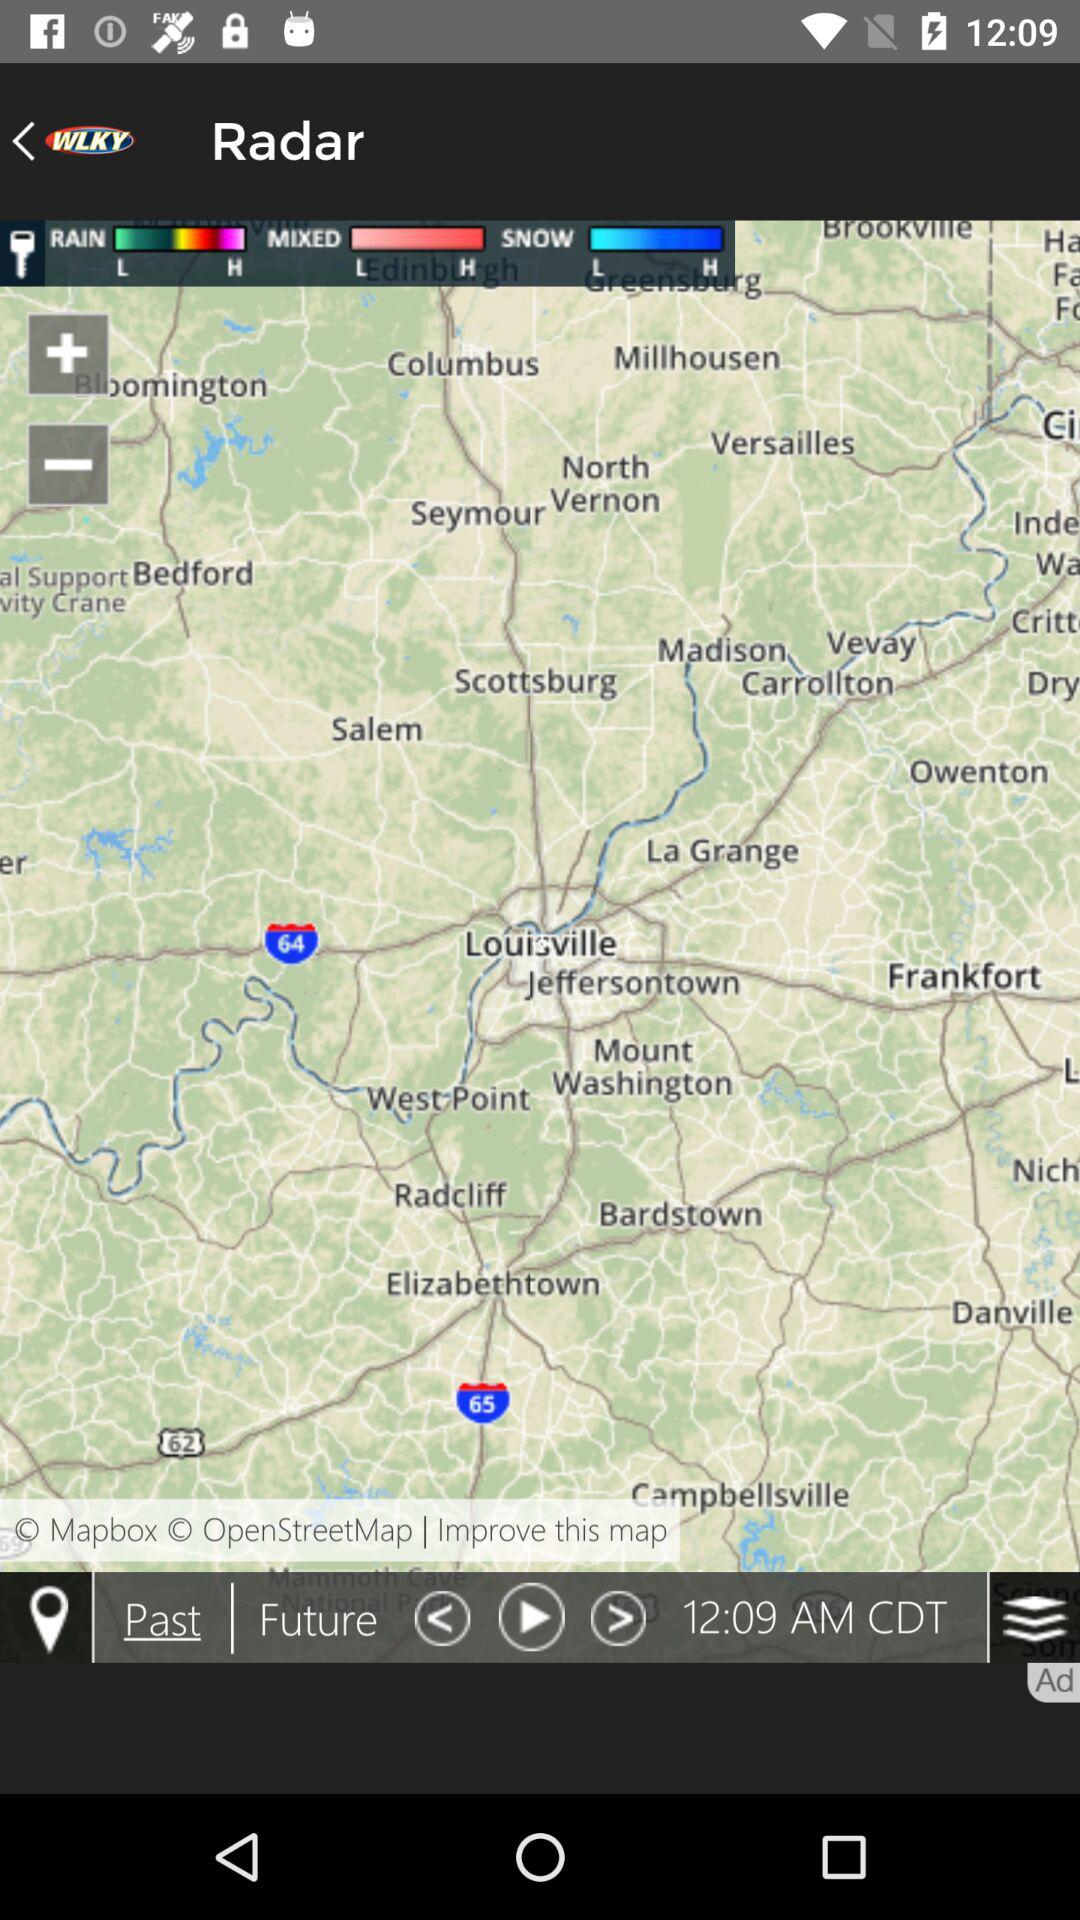What is the entered location?
When the provided information is insufficient, respond with <no answer>. <no answer> 